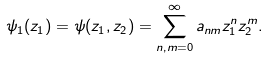Convert formula to latex. <formula><loc_0><loc_0><loc_500><loc_500>\psi _ { 1 } ( z _ { 1 } ) = \psi ( z _ { 1 } , z _ { 2 } ) = \sum _ { n , m = 0 } ^ { \infty } a _ { n m } z _ { 1 } ^ { n } z _ { 2 } ^ { m } .</formula> 